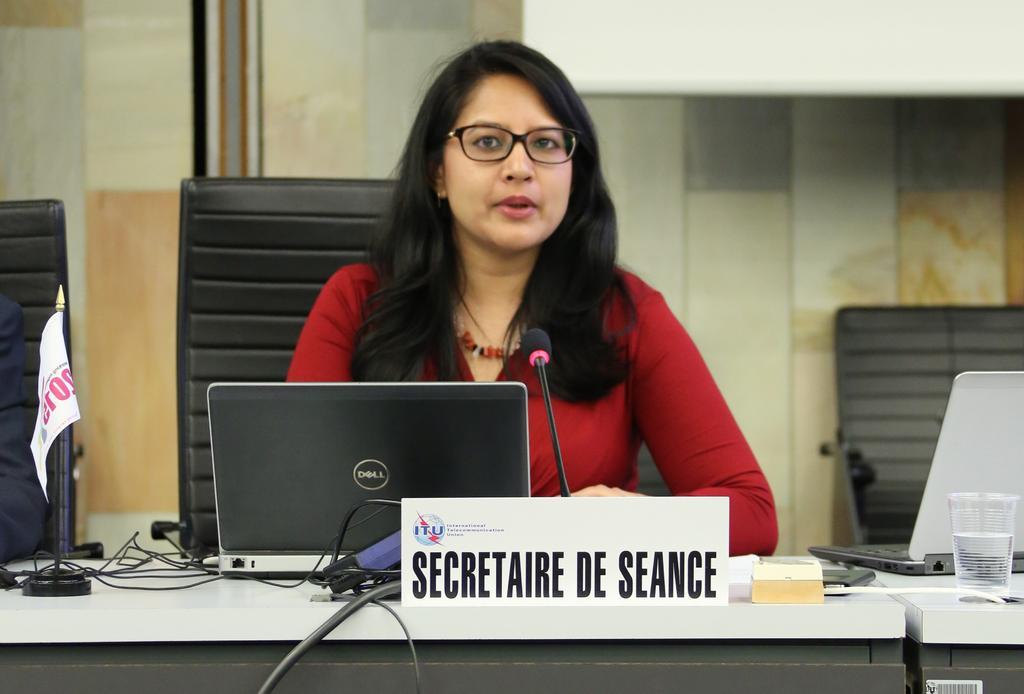In one or two sentences, can you explain what this image depicts? In the picture there is a woman wore red dress sat on chair talking on mic. There is laptop in front of her on a table. At the background wall is made up of tiles. There are glass,laptop,wires,flag on the table. 